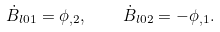Convert formula to latex. <formula><loc_0><loc_0><loc_500><loc_500>\dot { B } _ { l 0 1 } = \phi _ { , 2 } , \quad \dot { B } _ { l 0 2 } = - \phi _ { , 1 } .</formula> 